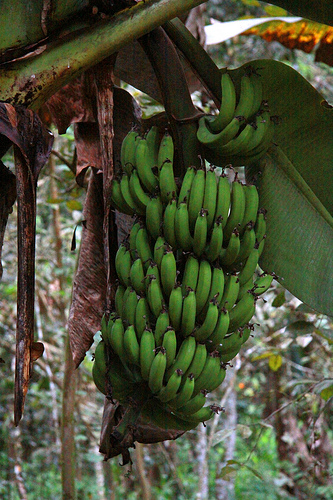Please provide a short description for this region: [0.58, 0.41, 0.62, 0.54]. This region shows a green banana. 